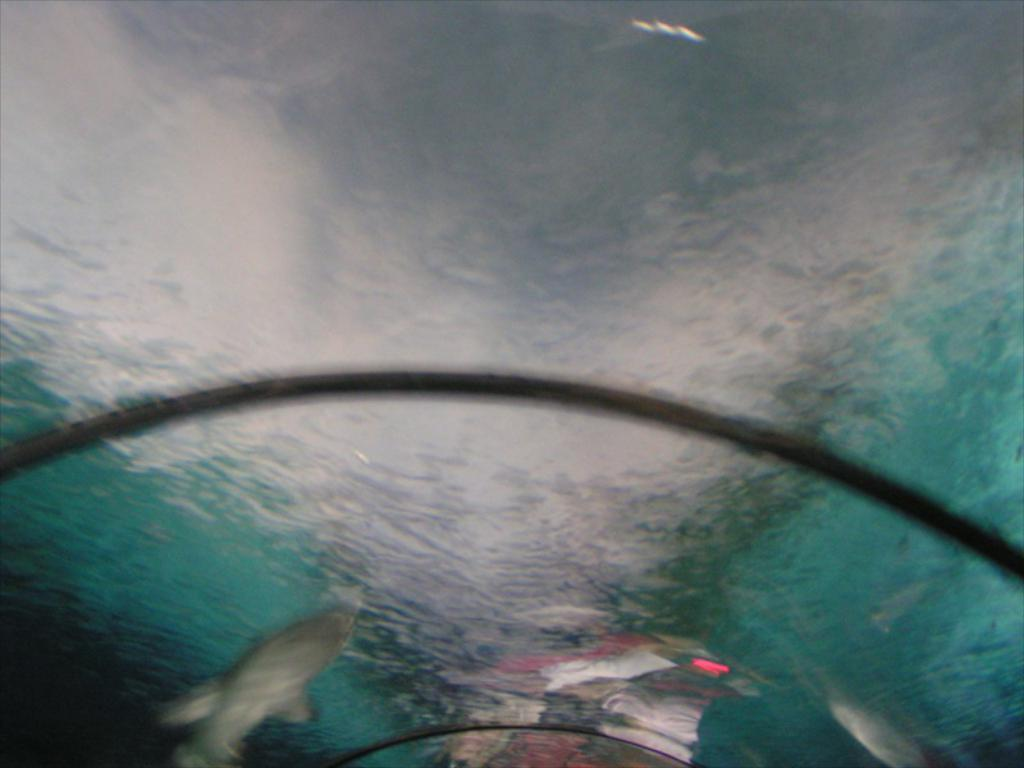What object is present in the image that can hold a liquid? There is a glass in the image that can hold a liquid. What liquid can be seen in the image? There is water visible in the image. What is visible on the surface of the glass? There is a reflection on the glass. What type of animal is at the bottom of the image? There is an aquatic animal at the bottom of the image. What type of balls can be seen on the plate in the image? There is no plate or balls present in the image. What type of paper is visible in the image? There is no paper visible in the image. 